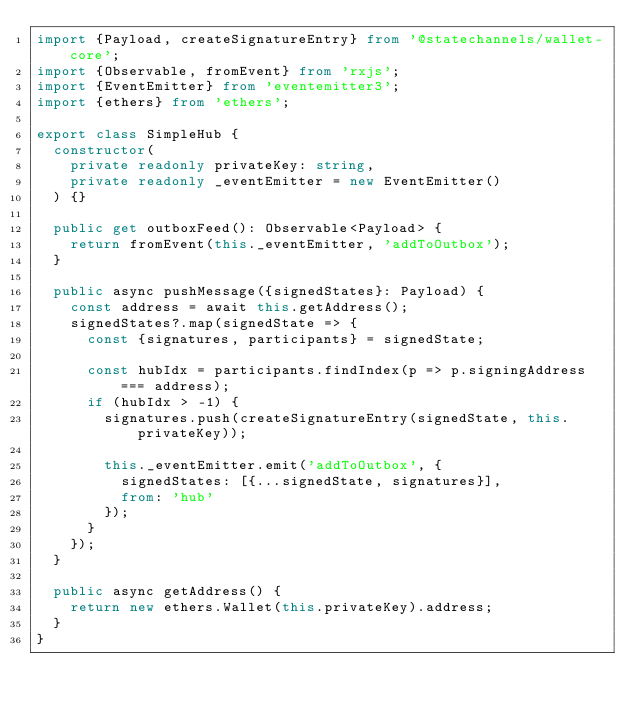<code> <loc_0><loc_0><loc_500><loc_500><_TypeScript_>import {Payload, createSignatureEntry} from '@statechannels/wallet-core';
import {Observable, fromEvent} from 'rxjs';
import {EventEmitter} from 'eventemitter3';
import {ethers} from 'ethers';

export class SimpleHub {
  constructor(
    private readonly privateKey: string,
    private readonly _eventEmitter = new EventEmitter()
  ) {}

  public get outboxFeed(): Observable<Payload> {
    return fromEvent(this._eventEmitter, 'addToOutbox');
  }

  public async pushMessage({signedStates}: Payload) {
    const address = await this.getAddress();
    signedStates?.map(signedState => {
      const {signatures, participants} = signedState;

      const hubIdx = participants.findIndex(p => p.signingAddress === address);
      if (hubIdx > -1) {
        signatures.push(createSignatureEntry(signedState, this.privateKey));

        this._eventEmitter.emit('addToOutbox', {
          signedStates: [{...signedState, signatures}],
          from: 'hub'
        });
      }
    });
  }

  public async getAddress() {
    return new ethers.Wallet(this.privateKey).address;
  }
}
</code> 